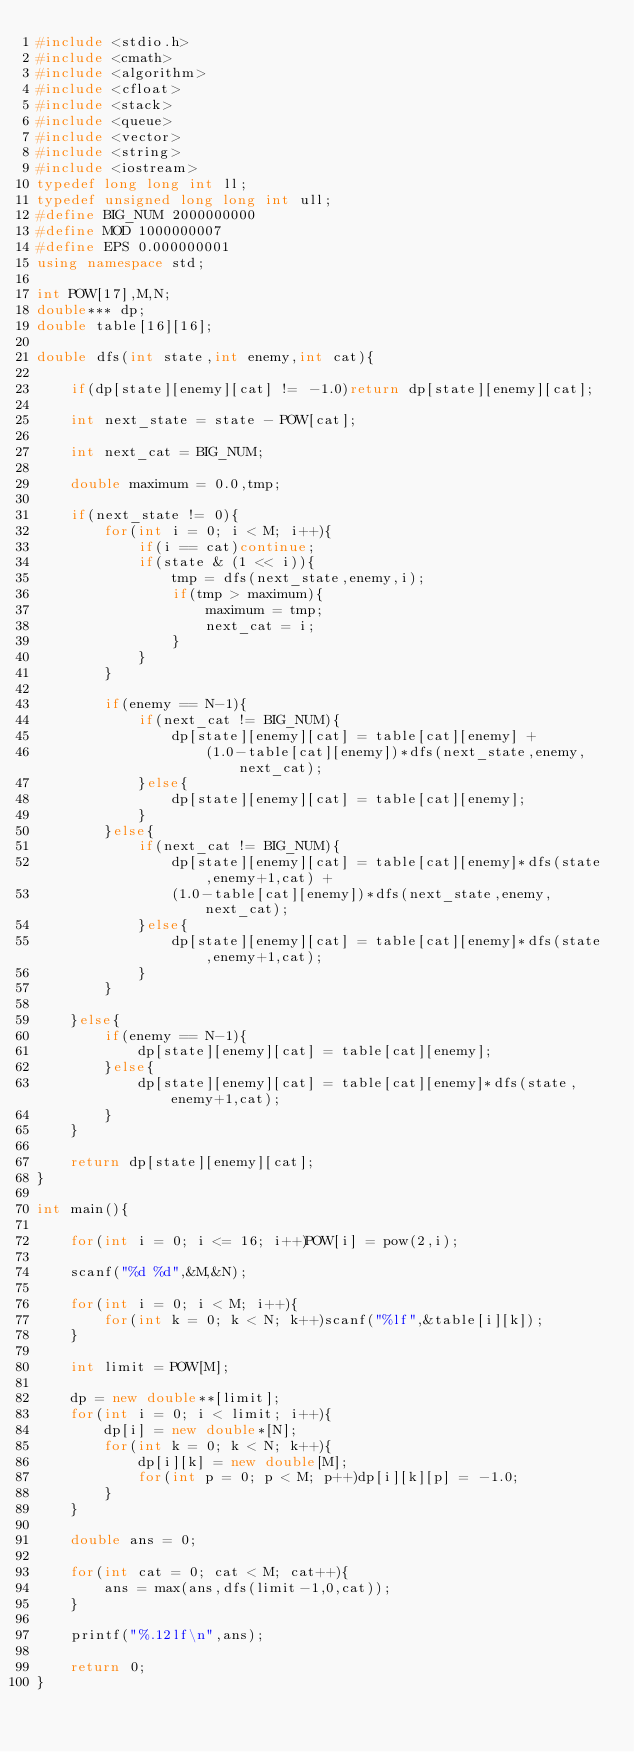Convert code to text. <code><loc_0><loc_0><loc_500><loc_500><_C++_>#include <stdio.h>
#include <cmath>
#include <algorithm>
#include <cfloat>
#include <stack>
#include <queue>
#include <vector>
#include <string>
#include <iostream>
typedef long long int ll;
typedef unsigned long long int ull;
#define BIG_NUM 2000000000
#define MOD 1000000007
#define EPS 0.000000001
using namespace std;

int POW[17],M,N;
double*** dp;
double table[16][16];

double dfs(int state,int enemy,int cat){

	if(dp[state][enemy][cat] != -1.0)return dp[state][enemy][cat];

	int next_state = state - POW[cat];

	int next_cat = BIG_NUM;

	double maximum = 0.0,tmp;

	if(next_state != 0){
		for(int i = 0; i < M; i++){
			if(i == cat)continue;
			if(state & (1 << i)){
				tmp = dfs(next_state,enemy,i);
				if(tmp > maximum){
					maximum = tmp;
					next_cat = i;
				}
			}
		}

		if(enemy == N-1){
			if(next_cat != BIG_NUM){
				dp[state][enemy][cat] = table[cat][enemy] +
					(1.0-table[cat][enemy])*dfs(next_state,enemy,next_cat);
			}else{
				dp[state][enemy][cat] = table[cat][enemy];
			}
		}else{
			if(next_cat != BIG_NUM){
				dp[state][enemy][cat] = table[cat][enemy]*dfs(state,enemy+1,cat) +
				(1.0-table[cat][enemy])*dfs(next_state,enemy,next_cat);
			}else{
				dp[state][enemy][cat] = table[cat][enemy]*dfs(state,enemy+1,cat);
			}
		}

	}else{
		if(enemy == N-1){
			dp[state][enemy][cat] = table[cat][enemy];
		}else{
			dp[state][enemy][cat] = table[cat][enemy]*dfs(state,enemy+1,cat);
		}
	}

	return dp[state][enemy][cat];
}

int main(){

	for(int i = 0; i <= 16; i++)POW[i] = pow(2,i);

	scanf("%d %d",&M,&N);

	for(int i = 0; i < M; i++){
		for(int k = 0; k < N; k++)scanf("%lf",&table[i][k]);
	}

	int limit = POW[M];

	dp = new double**[limit];
	for(int i = 0; i < limit; i++){
		dp[i] = new double*[N];
		for(int k = 0; k < N; k++){
			dp[i][k] = new double[M];
			for(int p = 0; p < M; p++)dp[i][k][p] = -1.0;
		}
	}

	double ans = 0;

	for(int cat = 0; cat < M; cat++){
		ans = max(ans,dfs(limit-1,0,cat));
	}

	printf("%.12lf\n",ans);

	return 0;
}</code> 